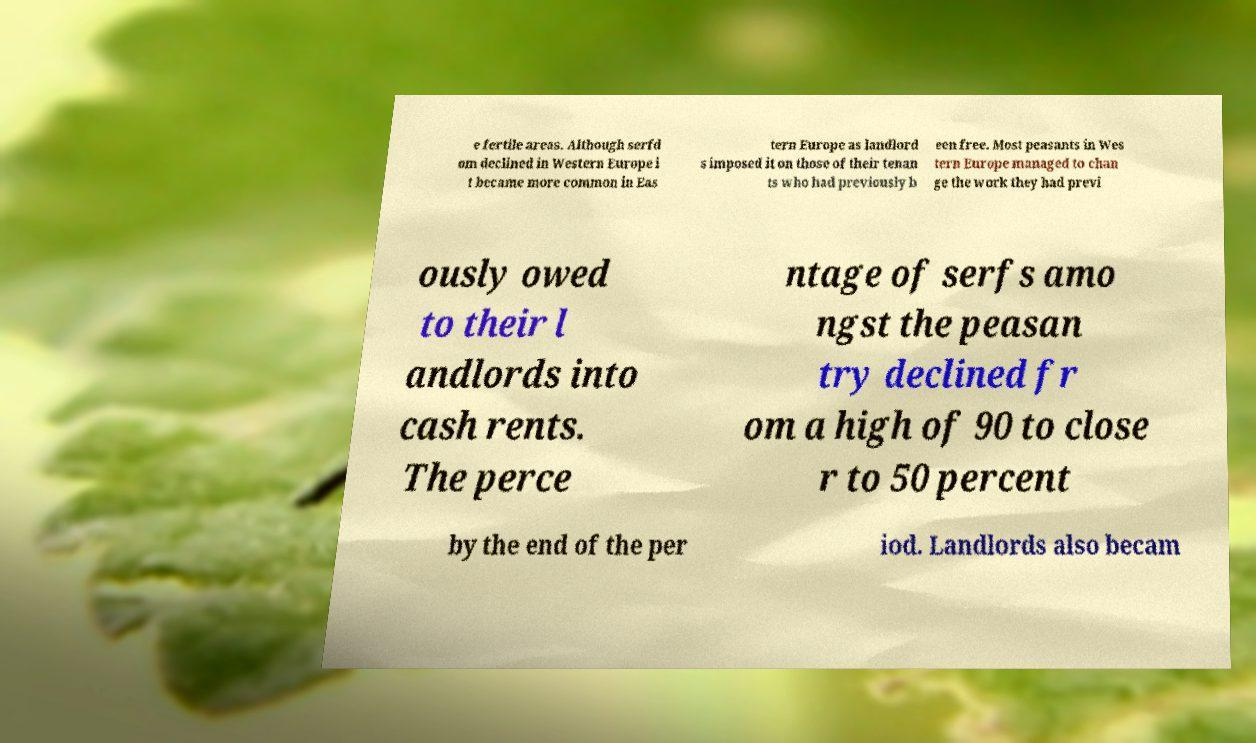Can you accurately transcribe the text from the provided image for me? e fertile areas. Although serfd om declined in Western Europe i t became more common in Eas tern Europe as landlord s imposed it on those of their tenan ts who had previously b een free. Most peasants in Wes tern Europe managed to chan ge the work they had previ ously owed to their l andlords into cash rents. The perce ntage of serfs amo ngst the peasan try declined fr om a high of 90 to close r to 50 percent by the end of the per iod. Landlords also becam 